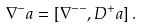Convert formula to latex. <formula><loc_0><loc_0><loc_500><loc_500>\nabla ^ { - } _ { \ } a = [ { \nabla } ^ { - - } , D ^ { + } _ { \ } a ] \, .</formula> 